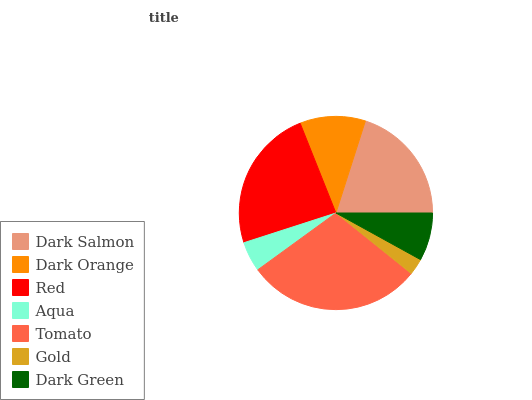Is Gold the minimum?
Answer yes or no. Yes. Is Tomato the maximum?
Answer yes or no. Yes. Is Dark Orange the minimum?
Answer yes or no. No. Is Dark Orange the maximum?
Answer yes or no. No. Is Dark Salmon greater than Dark Orange?
Answer yes or no. Yes. Is Dark Orange less than Dark Salmon?
Answer yes or no. Yes. Is Dark Orange greater than Dark Salmon?
Answer yes or no. No. Is Dark Salmon less than Dark Orange?
Answer yes or no. No. Is Dark Orange the high median?
Answer yes or no. Yes. Is Dark Orange the low median?
Answer yes or no. Yes. Is Dark Green the high median?
Answer yes or no. No. Is Aqua the low median?
Answer yes or no. No. 